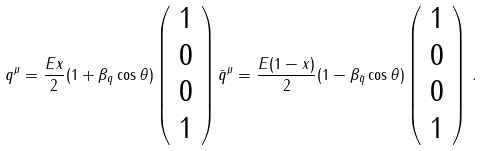<formula> <loc_0><loc_0><loc_500><loc_500>q ^ { \mu } = \frac { E x } { 2 } ( 1 + \beta _ { q } \cos \theta ) \left ( \begin{array} { c } 1 \\ 0 \\ 0 \\ 1 \end{array} \right ) \bar { q } ^ { \mu } = \frac { E ( 1 - x ) } { 2 } ( 1 - \beta _ { \bar { q } } \cos \theta ) \left ( \begin{array} { c } 1 \\ 0 \\ 0 \\ 1 \end{array} \right ) \, .</formula> 